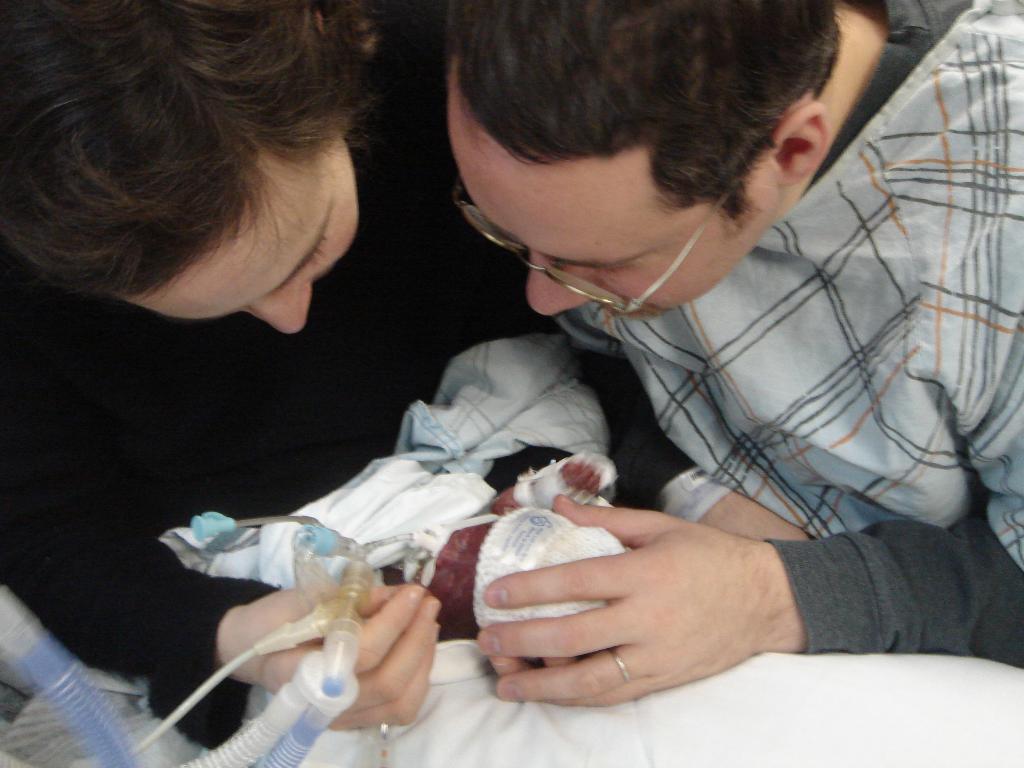Could you give a brief overview of what you see in this image? In the picture I can see two persons and they are looking at a baby. This is looking like an oxygen supply pipe on the bottom left side. 